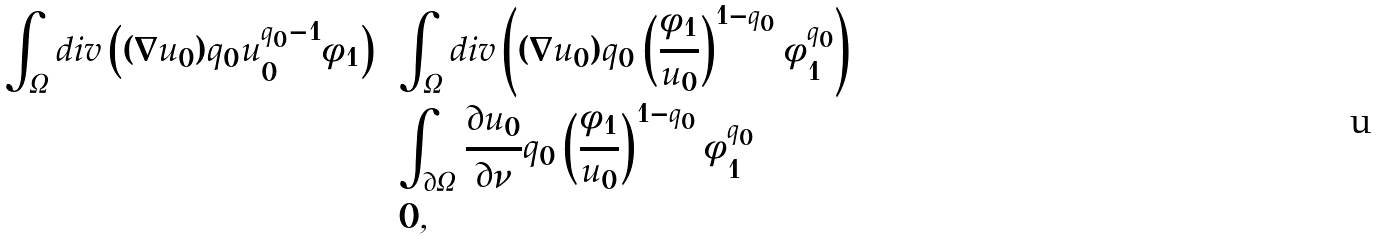Convert formula to latex. <formula><loc_0><loc_0><loc_500><loc_500>\int _ { \Omega } d i v \left ( ( \nabla u _ { 0 } ) q _ { 0 } u _ { 0 } ^ { q _ { 0 } - 1 } \phi _ { 1 } \right ) & = \int _ { \Omega } d i v \left ( ( \nabla u _ { 0 } ) q _ { 0 } \left ( \frac { \phi _ { 1 } } { u _ { 0 } } \right ) ^ { 1 - q _ { 0 } } \phi _ { 1 } ^ { q _ { 0 } } \right ) \\ & = \int _ { \partial \Omega } \frac { \partial u _ { 0 } } { \partial \nu } q _ { 0 } \left ( \frac { \phi _ { 1 } } { u _ { 0 } } \right ) ^ { 1 - q _ { 0 } } \phi _ { 1 } ^ { q _ { 0 } } \\ & = 0 ,</formula> 